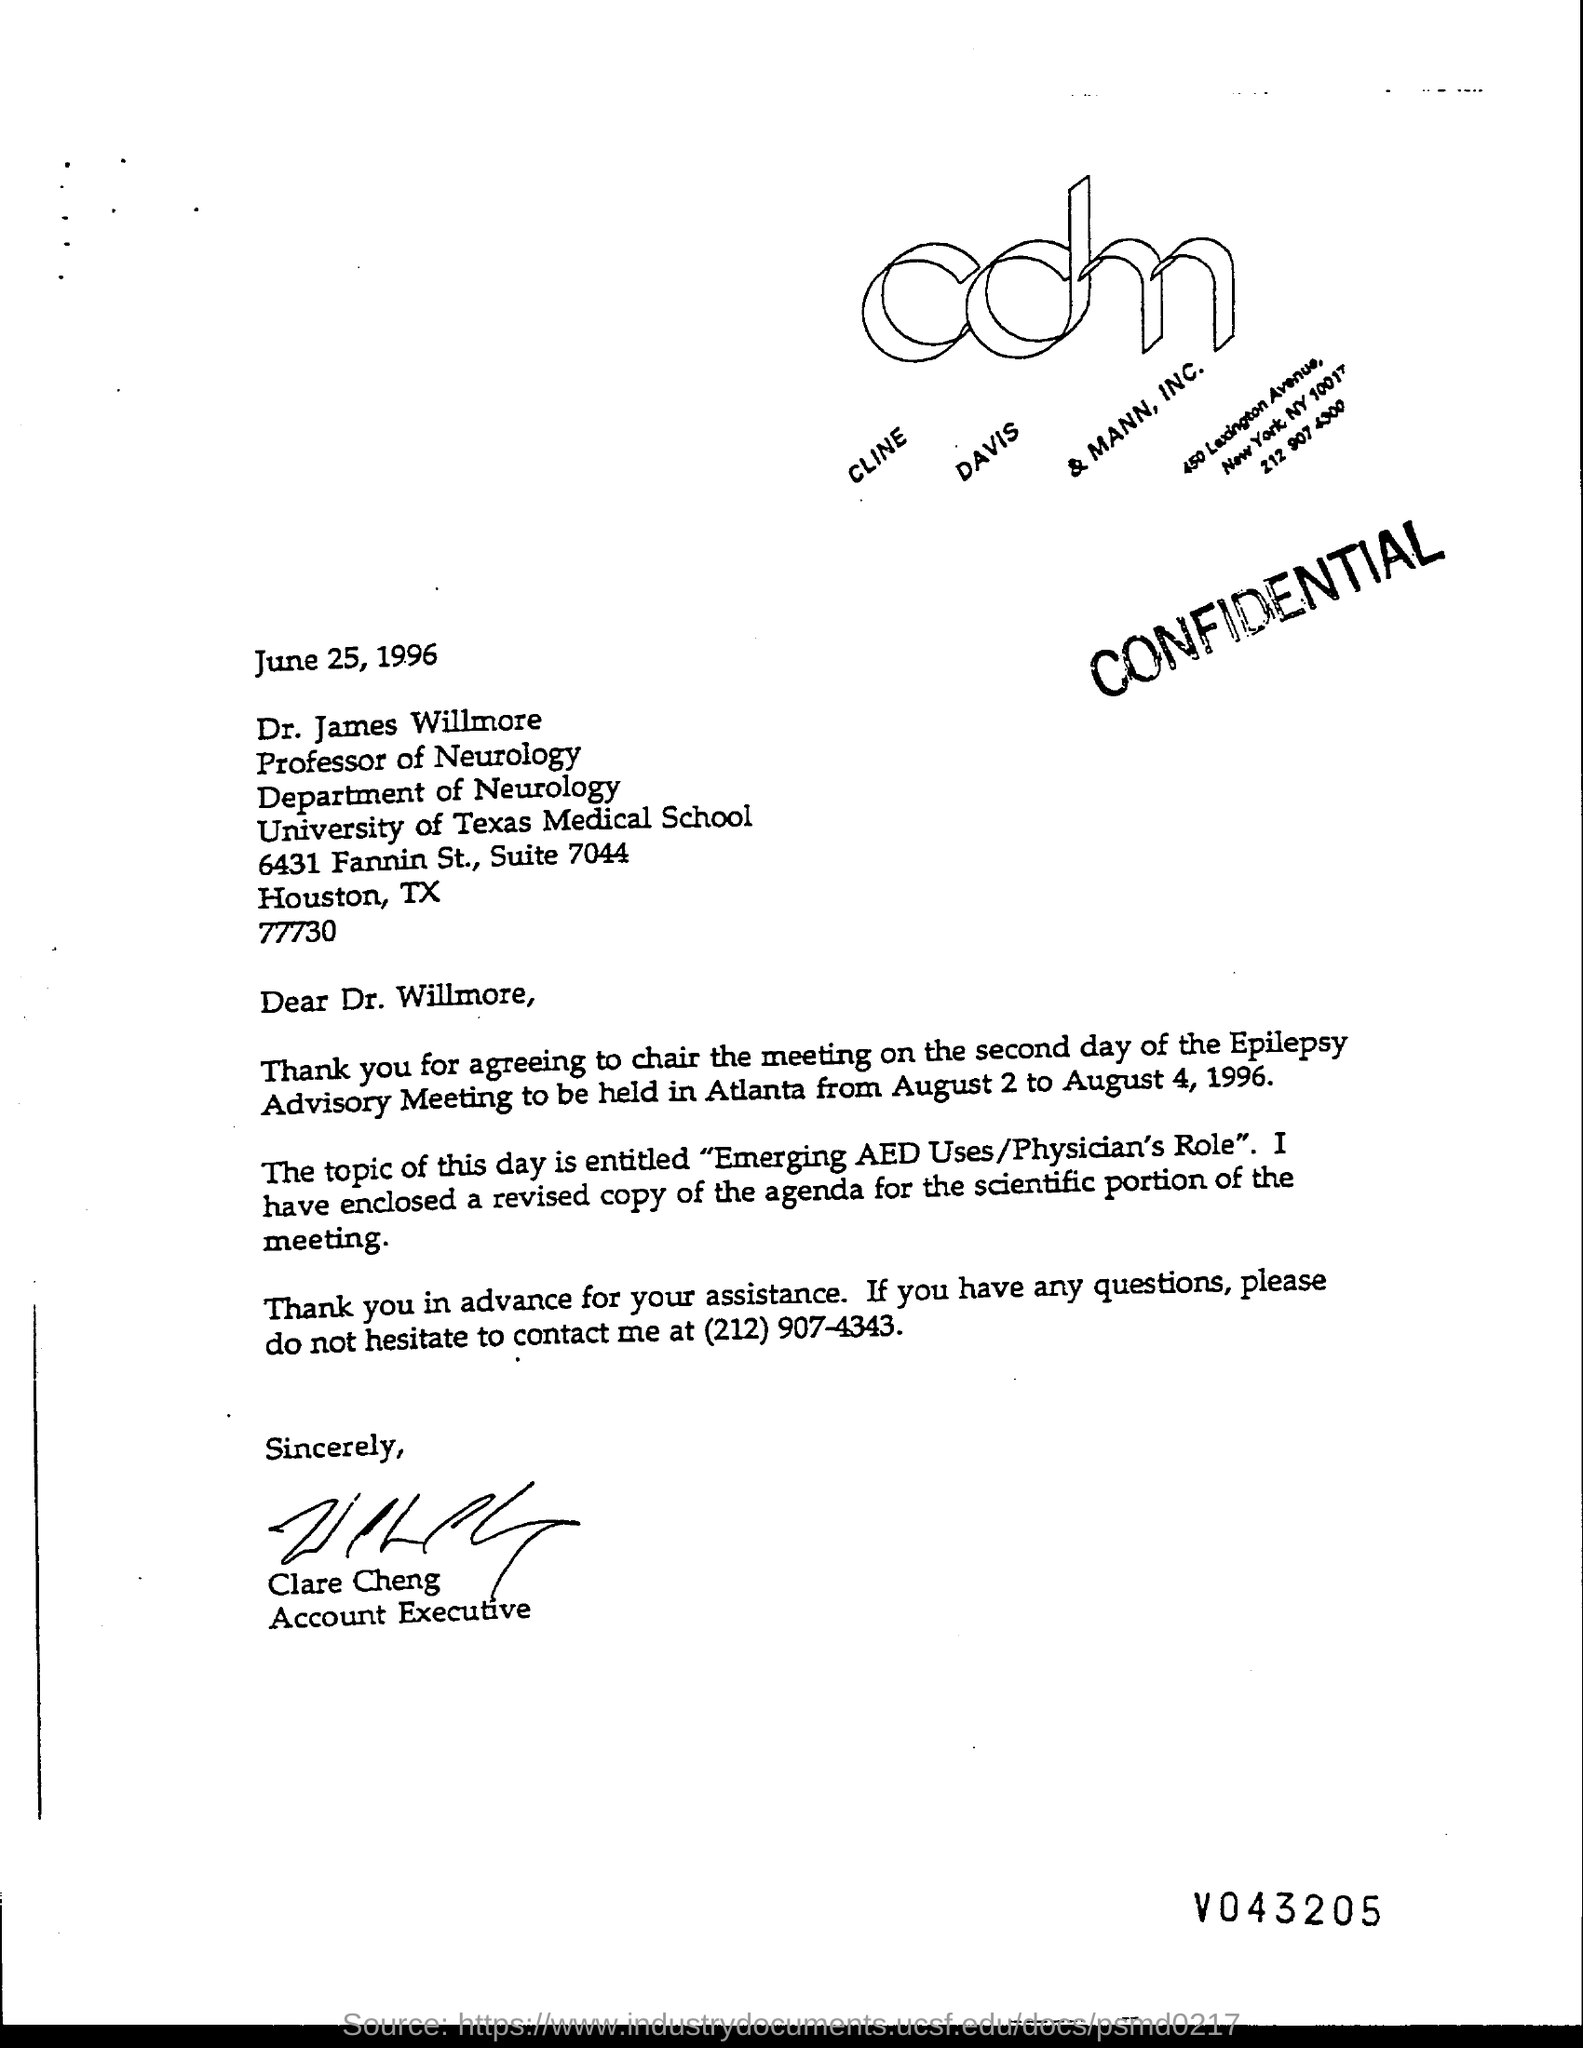What is the issued date of this letter?
Offer a very short reply. June 25, 1996. What is the designation of Dr. James Willmore?
Ensure brevity in your answer.  Professor of Neurology. Who has signed this letter?
Provide a succinct answer. Clare Cheng. What is the designation of Clare Cheng?
Offer a very short reply. Account Executive. 